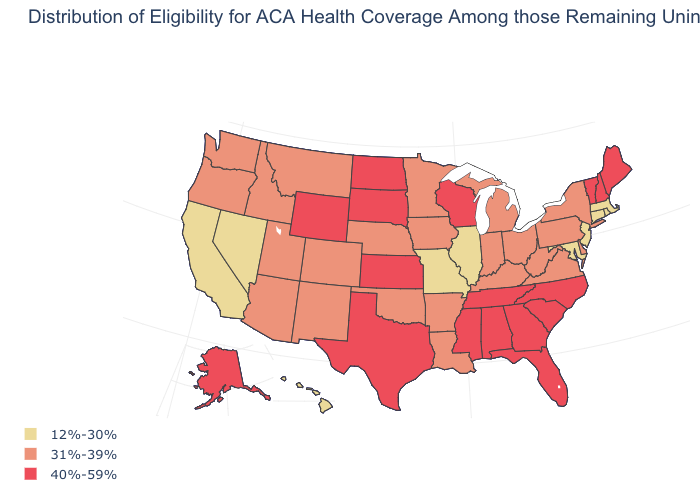Among the states that border Vermont , which have the lowest value?
Quick response, please. Massachusetts. What is the value of Kansas?
Answer briefly. 40%-59%. What is the value of Michigan?
Answer briefly. 31%-39%. How many symbols are there in the legend?
Concise answer only. 3. What is the lowest value in the USA?
Give a very brief answer. 12%-30%. Name the states that have a value in the range 40%-59%?
Answer briefly. Alabama, Alaska, Florida, Georgia, Kansas, Maine, Mississippi, New Hampshire, North Carolina, North Dakota, South Carolina, South Dakota, Tennessee, Texas, Vermont, Wisconsin, Wyoming. What is the value of Nevada?
Write a very short answer. 12%-30%. What is the lowest value in the USA?
Write a very short answer. 12%-30%. What is the lowest value in the MidWest?
Keep it brief. 12%-30%. What is the lowest value in the MidWest?
Write a very short answer. 12%-30%. Which states have the lowest value in the USA?
Be succinct. California, Connecticut, Hawaii, Illinois, Maryland, Massachusetts, Missouri, Nevada, New Jersey, Rhode Island. What is the value of Indiana?
Keep it brief. 31%-39%. Does the first symbol in the legend represent the smallest category?
Quick response, please. Yes. Name the states that have a value in the range 40%-59%?
Give a very brief answer. Alabama, Alaska, Florida, Georgia, Kansas, Maine, Mississippi, New Hampshire, North Carolina, North Dakota, South Carolina, South Dakota, Tennessee, Texas, Vermont, Wisconsin, Wyoming. What is the value of Minnesota?
Quick response, please. 31%-39%. 